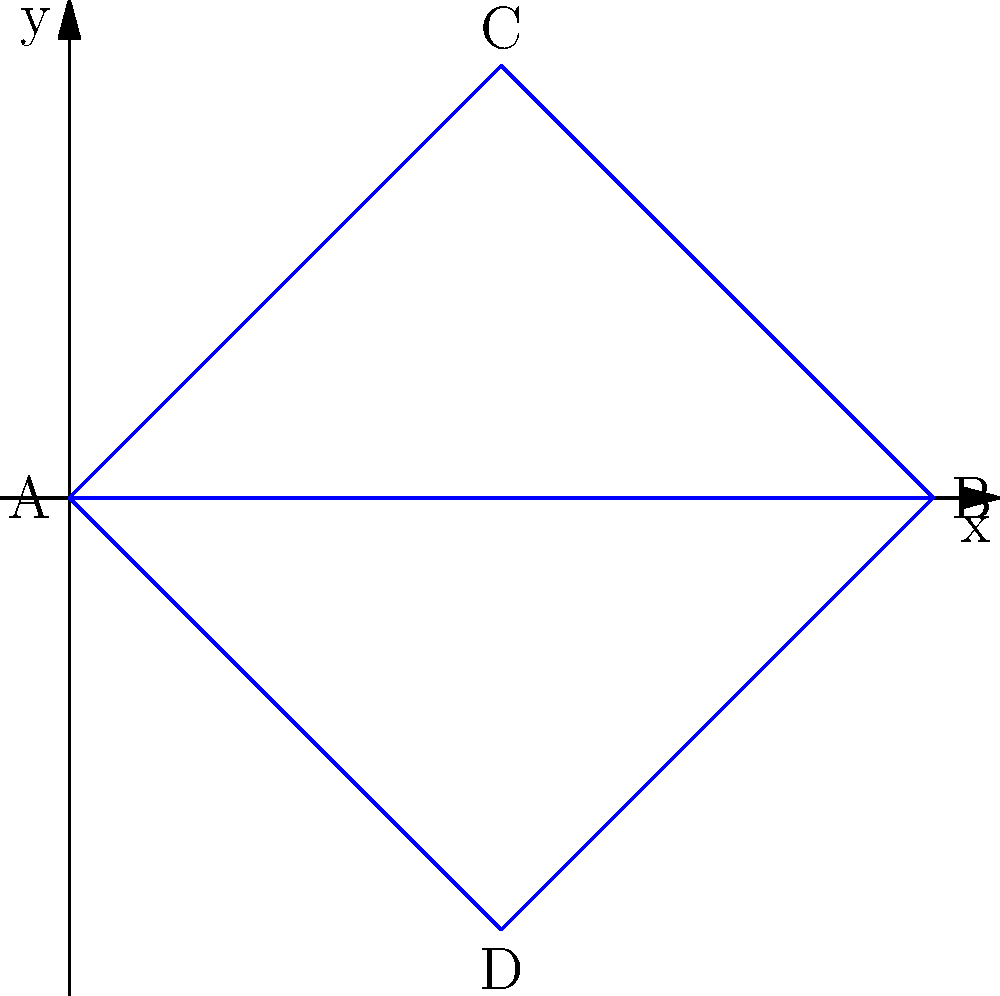In the context of planning a human rights protest march, consider the topological properties of the three routes shown in the diagram. Which route would likely have the highest visibility and impact, assuming that the number of intersections with other paths correlates with increased public awareness? To determine which route has the highest visibility and impact, we need to analyze the topological properties of each path, focusing on the number of intersections:

1. Route ACB: This route goes from A to C to B.
   - It intersects with route AB at points A and B.
   - It intersects with route ADB at point A.
   - Total intersections: 2

2. Route AB: This route goes directly from A to B.
   - It intersects with route ACB at points A and B.
   - It intersects with route ADB at points A and B.
   - Total intersections: 2

3. Route ADB: This route goes from A to D to B.
   - It intersects with route AB at points A and B.
   - It intersects with route ACB at point A.
   - Total intersections: 2

Although all routes have the same number of intersections, we need to consider the nature of these intersections:

- Route ACB and route ADB create a more complex topological structure by forming a "loop" with route AB.
- This loop creates a central area (enclosed space) that could potentially attract more attention.
- Between ACB and ADB, the route ACB goes "above" the direct path, which might be more visible in an urban setting where observers may be looking up from ground level.

Therefore, based on topological properties and potential visibility, route ACB would likely have the highest visibility and impact.
Answer: Route ACB 